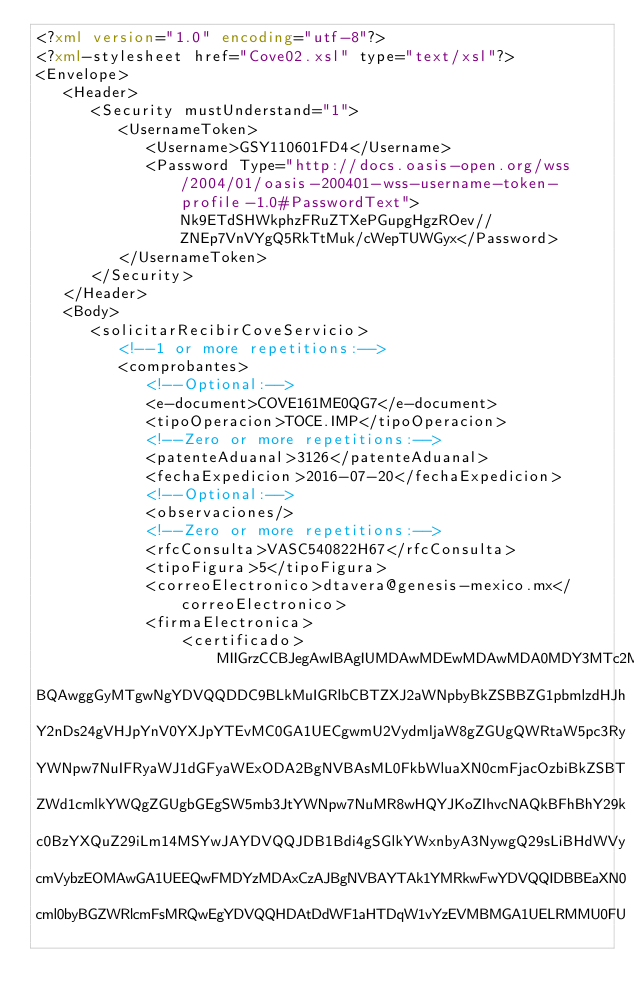Convert code to text. <code><loc_0><loc_0><loc_500><loc_500><_XML_><?xml version="1.0" encoding="utf-8"?>
<?xml-stylesheet href="Cove02.xsl" type="text/xsl"?>
<Envelope>
   <Header>
      <Security mustUnderstand="1">
         <UsernameToken>
            <Username>GSY110601FD4</Username>
            <Password Type="http://docs.oasis-open.org/wss/2004/01/oasis-200401-wss-username-token-profile-1.0#PasswordText">Nk9ETdSHWkphzFRuZTXePGupgHgzROev//ZNEp7VnVYgQ5RkTtMuk/cWepTUWGyx</Password>
         </UsernameToken>
      </Security>
   </Header>
   <Body>
      <solicitarRecibirCoveServicio>
         <!--1 or more repetitions:-->
         <comprobantes>
            <!--Optional:-->
            <e-document>COVE161ME0QG7</e-document>
            <tipoOperacion>TOCE.IMP</tipoOperacion>
            <!--Zero or more repetitions:-->
            <patenteAduanal>3126</patenteAduanal>
            <fechaExpedicion>2016-07-20</fechaExpedicion>
            <!--Optional:-->
            <observaciones/>
            <!--Zero or more repetitions:-->
            <rfcConsulta>VASC540822H67</rfcConsulta>
            <tipoFigura>5</tipoFigura>
            <correoElectronico>dtavera@genesis-mexico.mx</correoElectronico>
            <firmaElectronica>
            	<certificado>MIIGrzCCBJegAwIBAgIUMDAwMDEwMDAwMDA0MDY3MTc2MTcwDQYJKoZIhvcNAQEL
BQAwggGyMTgwNgYDVQQDDC9BLkMuIGRlbCBTZXJ2aWNpbyBkZSBBZG1pbmlzdHJh
Y2nDs24gVHJpYnV0YXJpYTEvMC0GA1UECgwmU2VydmljaW8gZGUgQWRtaW5pc3Ry
YWNpw7NuIFRyaWJ1dGFyaWExODA2BgNVBAsML0FkbWluaXN0cmFjacOzbiBkZSBT
ZWd1cmlkYWQgZGUgbGEgSW5mb3JtYWNpw7NuMR8wHQYJKoZIhvcNAQkBFhBhY29k
c0BzYXQuZ29iLm14MSYwJAYDVQQJDB1Bdi4gSGlkYWxnbyA3NywgQ29sLiBHdWVy
cmVybzEOMAwGA1UEEQwFMDYzMDAxCzAJBgNVBAYTAk1YMRkwFwYDVQQIDBBEaXN0
cml0byBGZWRlcmFsMRQwEgYDVQQHDAtDdWF1aHTDqW1vYzEVMBMGA1UELRMMU0FU</code> 